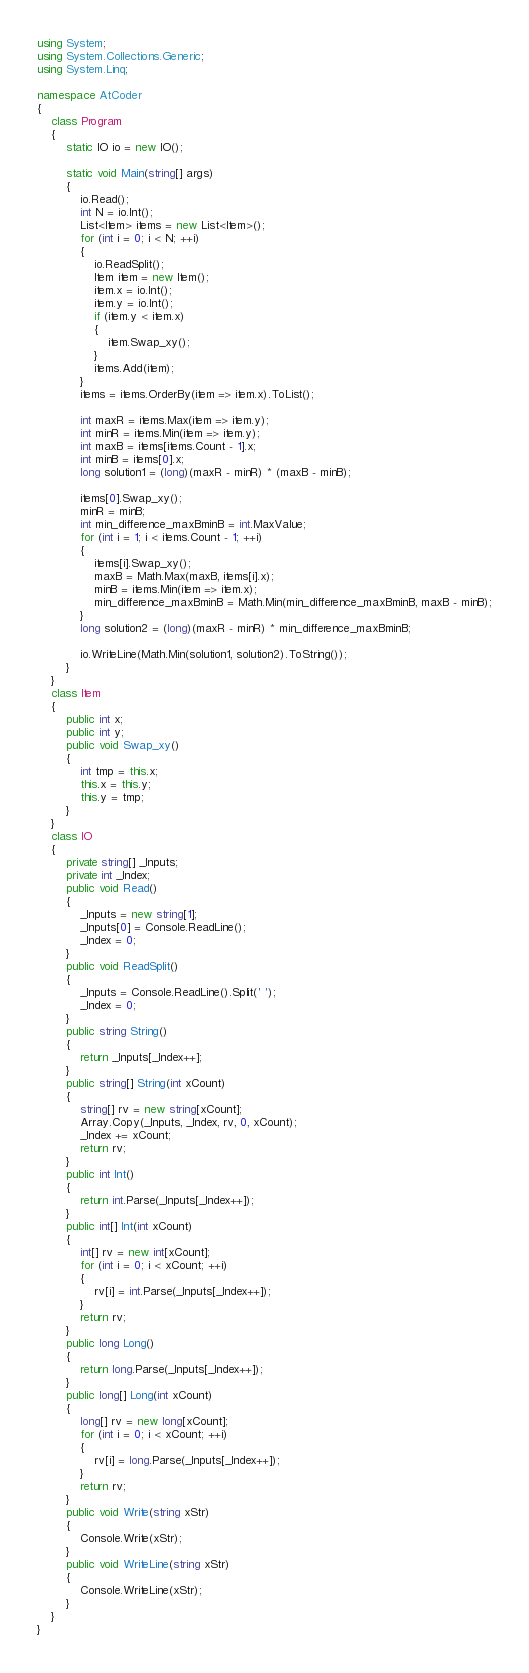<code> <loc_0><loc_0><loc_500><loc_500><_C#_>using System;
using System.Collections.Generic;
using System.Linq;

namespace AtCoder
{
    class Program
    {
        static IO io = new IO();

        static void Main(string[] args)
        {
            io.Read();
            int N = io.Int();
            List<Item> items = new List<Item>();
            for (int i = 0; i < N; ++i)
            {
                io.ReadSplit();
                Item item = new Item();
                item.x = io.Int();
                item.y = io.Int();
                if (item.y < item.x)
                {
                    item.Swap_xy();
                }
                items.Add(item);
            }
            items = items.OrderBy(item => item.x).ToList();

            int maxR = items.Max(item => item.y);
            int minR = items.Min(item => item.y);
            int maxB = items[items.Count - 1].x;
            int minB = items[0].x;
            long solution1 = (long)(maxR - minR) * (maxB - minB);

            items[0].Swap_xy();
            minR = minB;
            int min_difference_maxBminB = int.MaxValue;
            for (int i = 1; i < items.Count - 1; ++i)
            {
                items[i].Swap_xy();
                maxB = Math.Max(maxB, items[i].x);
                minB = items.Min(item => item.x);
                min_difference_maxBminB = Math.Min(min_difference_maxBminB, maxB - minB);
            }
            long solution2 = (long)(maxR - minR) * min_difference_maxBminB;

            io.WriteLine(Math.Min(solution1, solution2).ToString());
        }
    }
    class Item
    {
        public int x;
        public int y;
        public void Swap_xy()
        {
            int tmp = this.x;
            this.x = this.y;
            this.y = tmp;
        }
    }
    class IO
    {
        private string[] _Inputs;
        private int _Index;
        public void Read()
        {
            _Inputs = new string[1];
            _Inputs[0] = Console.ReadLine();
            _Index = 0;
        }
        public void ReadSplit()
        {
            _Inputs = Console.ReadLine().Split(' ');
            _Index = 0;
        }
        public string String()
        {
            return _Inputs[_Index++];
        }
        public string[] String(int xCount)
        {
            string[] rv = new string[xCount];
            Array.Copy(_Inputs, _Index, rv, 0, xCount);
            _Index += xCount;
            return rv;
        }
        public int Int()
        {
            return int.Parse(_Inputs[_Index++]);
        }
        public int[] Int(int xCount)
        {
            int[] rv = new int[xCount];
            for (int i = 0; i < xCount; ++i)
            {
                rv[i] = int.Parse(_Inputs[_Index++]);
            }
            return rv;
        }
        public long Long()
        {
            return long.Parse(_Inputs[_Index++]);
        }
        public long[] Long(int xCount)
        {
            long[] rv = new long[xCount];
            for (int i = 0; i < xCount; ++i)
            {
                rv[i] = long.Parse(_Inputs[_Index++]);
            }
            return rv;
        }
        public void Write(string xStr)
        {
            Console.Write(xStr);
        }
        public void WriteLine(string xStr)
        {
            Console.WriteLine(xStr);
        }
    }
}</code> 